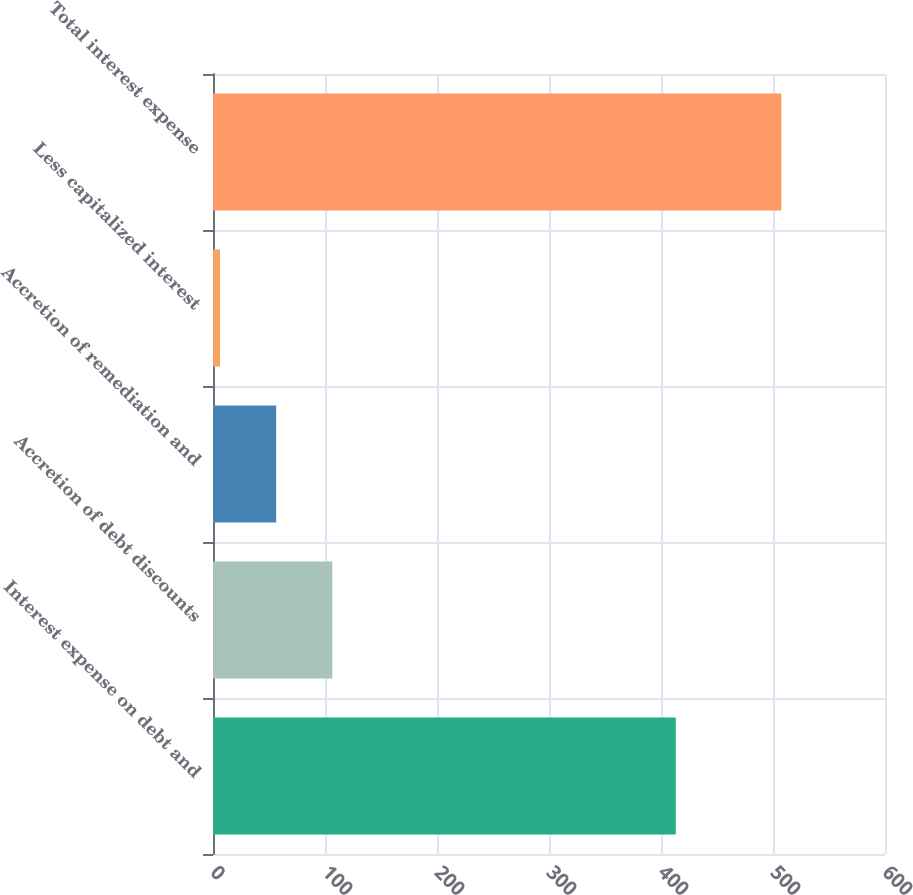<chart> <loc_0><loc_0><loc_500><loc_500><bar_chart><fcel>Interest expense on debt and<fcel>Accretion of debt discounts<fcel>Accretion of remediation and<fcel>Less capitalized interest<fcel>Total interest expense<nl><fcel>413.2<fcel>106.52<fcel>56.41<fcel>6.3<fcel>507.4<nl></chart> 